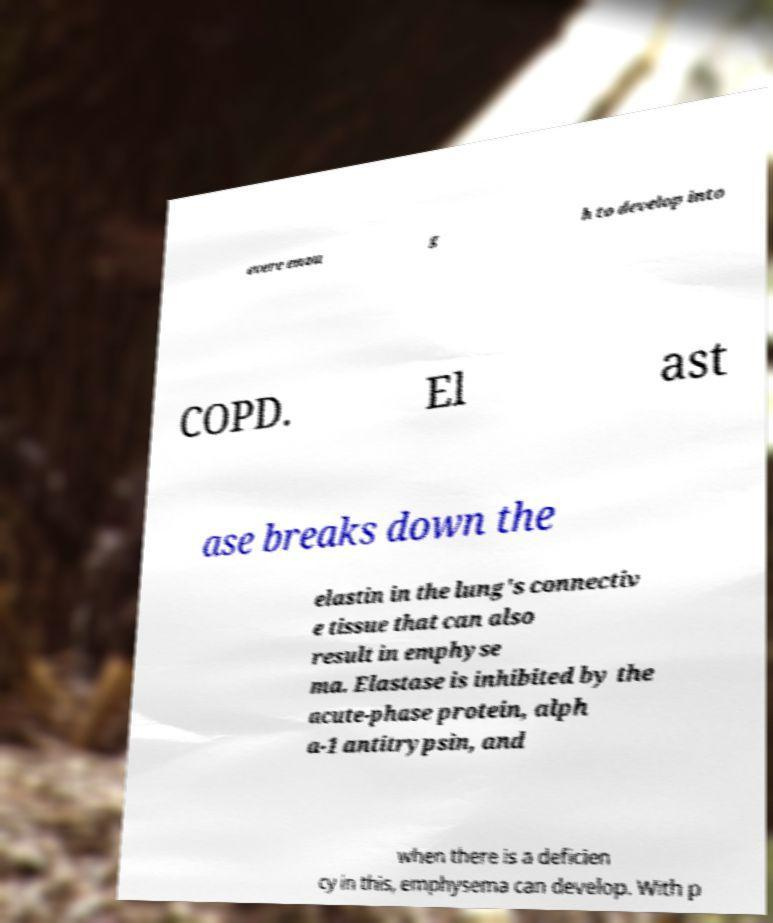I need the written content from this picture converted into text. Can you do that? evere enou g h to develop into COPD. El ast ase breaks down the elastin in the lung's connectiv e tissue that can also result in emphyse ma. Elastase is inhibited by the acute-phase protein, alph a-1 antitrypsin, and when there is a deficien cy in this, emphysema can develop. With p 